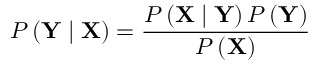<formula> <loc_0><loc_0><loc_500><loc_500>P \left ( Y | X \right ) = \frac { P \left ( X | Y \right ) P \left ( Y \right ) } { P \left ( X \right ) }</formula> 